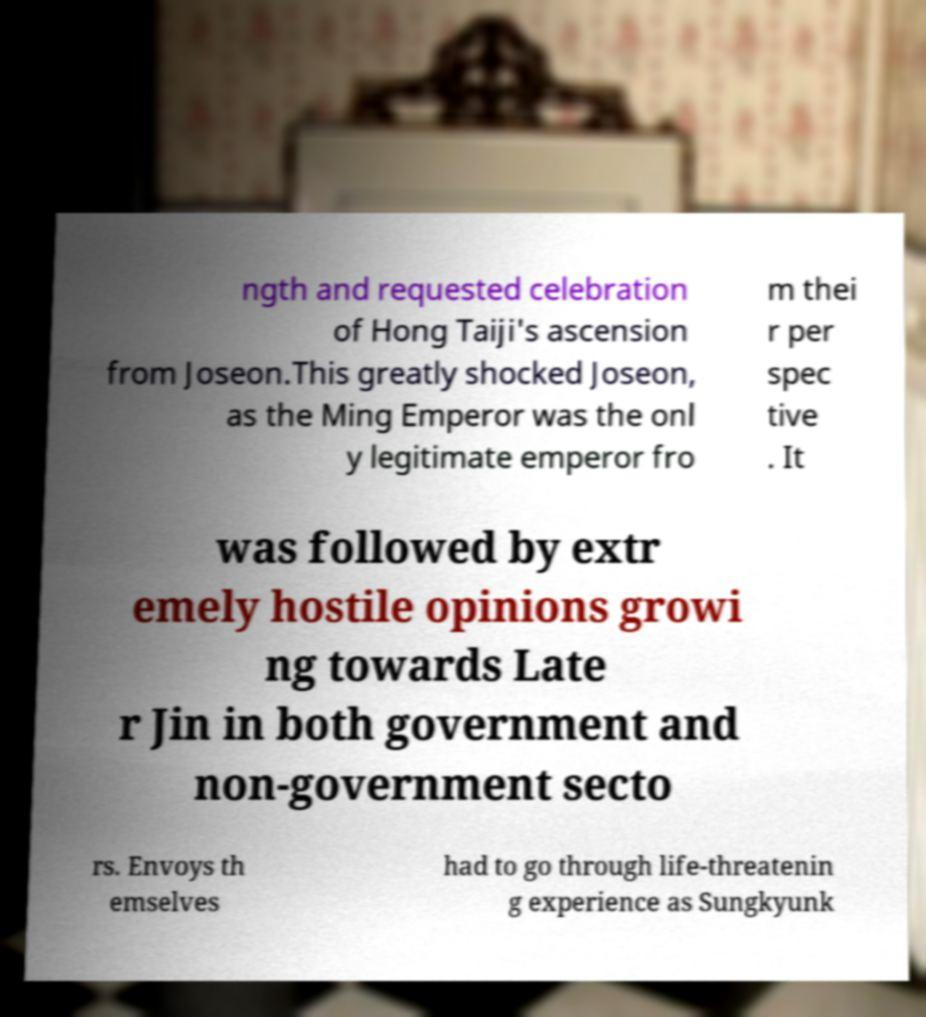I need the written content from this picture converted into text. Can you do that? ngth and requested celebration of Hong Taiji's ascension from Joseon.This greatly shocked Joseon, as the Ming Emperor was the onl y legitimate emperor fro m thei r per spec tive . It was followed by extr emely hostile opinions growi ng towards Late r Jin in both government and non-government secto rs. Envoys th emselves had to go through life-threatenin g experience as Sungkyunk 